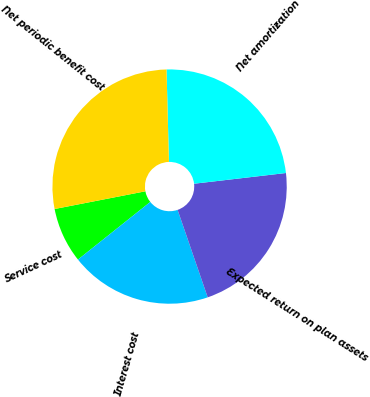Convert chart. <chart><loc_0><loc_0><loc_500><loc_500><pie_chart><fcel>Service cost<fcel>Interest cost<fcel>Expected return on plan assets<fcel>Net amortization<fcel>Net periodic benefit cost<nl><fcel>7.64%<fcel>19.57%<fcel>21.57%<fcel>23.57%<fcel>27.65%<nl></chart> 